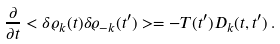Convert formula to latex. <formula><loc_0><loc_0><loc_500><loc_500>\frac { \partial } { \partial t } < \delta \varrho _ { k } ( t ) \delta \varrho _ { - k } ( t ^ { \prime } ) > = - T ( t ^ { \prime } ) D _ { k } ( t , t ^ { \prime } ) \, .</formula> 